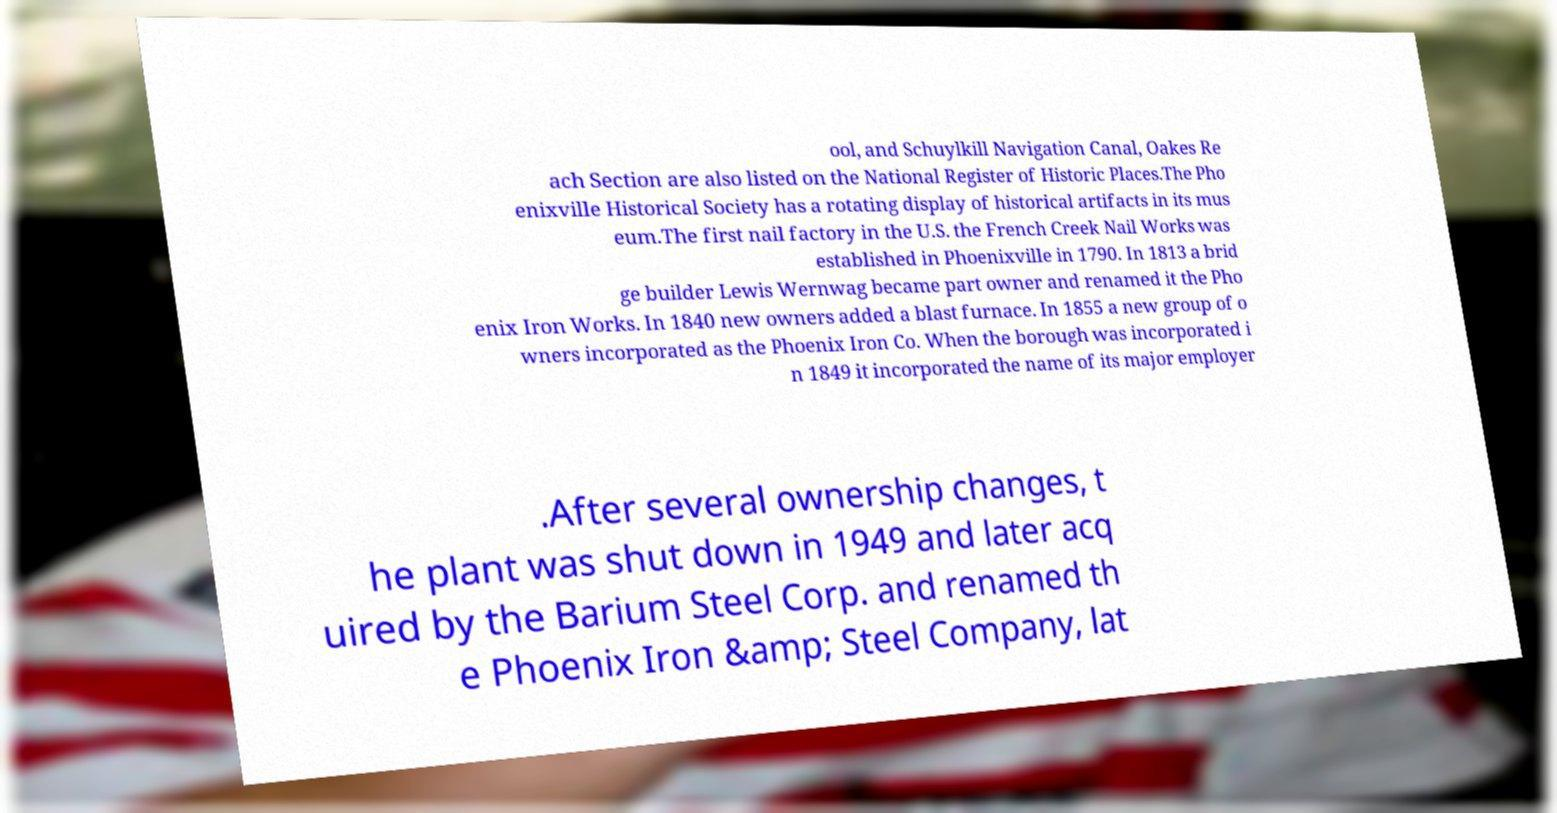For documentation purposes, I need the text within this image transcribed. Could you provide that? ool, and Schuylkill Navigation Canal, Oakes Re ach Section are also listed on the National Register of Historic Places.The Pho enixville Historical Society has a rotating display of historical artifacts in its mus eum.The first nail factory in the U.S. the French Creek Nail Works was established in Phoenixville in 1790. In 1813 a brid ge builder Lewis Wernwag became part owner and renamed it the Pho enix Iron Works. In 1840 new owners added a blast furnace. In 1855 a new group of o wners incorporated as the Phoenix Iron Co. When the borough was incorporated i n 1849 it incorporated the name of its major employer .After several ownership changes, t he plant was shut down in 1949 and later acq uired by the Barium Steel Corp. and renamed th e Phoenix Iron &amp; Steel Company, lat 